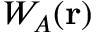Convert formula to latex. <formula><loc_0><loc_0><loc_500><loc_500>W _ { A } ( r )</formula> 